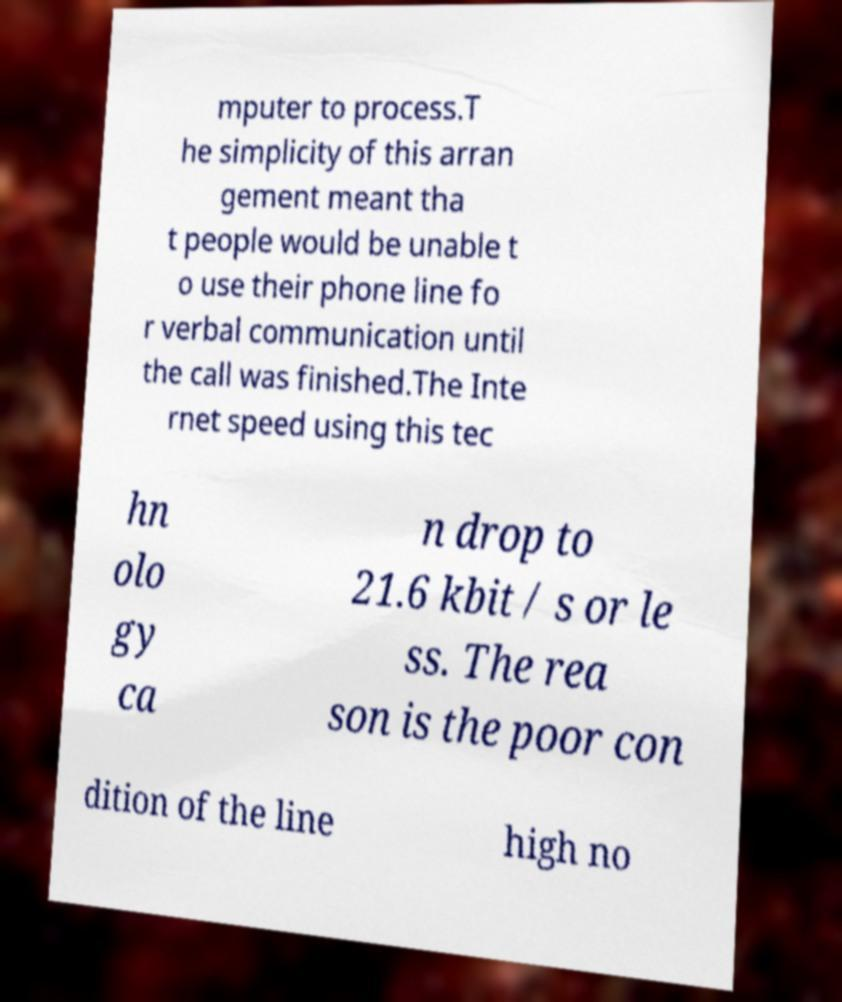Can you read and provide the text displayed in the image?This photo seems to have some interesting text. Can you extract and type it out for me? mputer to process.T he simplicity of this arran gement meant tha t people would be unable t o use their phone line fo r verbal communication until the call was finished.The Inte rnet speed using this tec hn olo gy ca n drop to 21.6 kbit / s or le ss. The rea son is the poor con dition of the line high no 